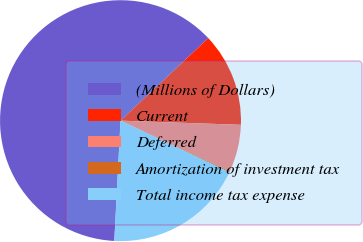<chart> <loc_0><loc_0><loc_500><loc_500><pie_chart><fcel>(Millions of Dollars)<fcel>Current<fcel>Deferred<fcel>Amortization of investment tax<fcel>Total income tax expense<nl><fcel>62.17%<fcel>12.56%<fcel>6.36%<fcel>0.15%<fcel>18.76%<nl></chart> 